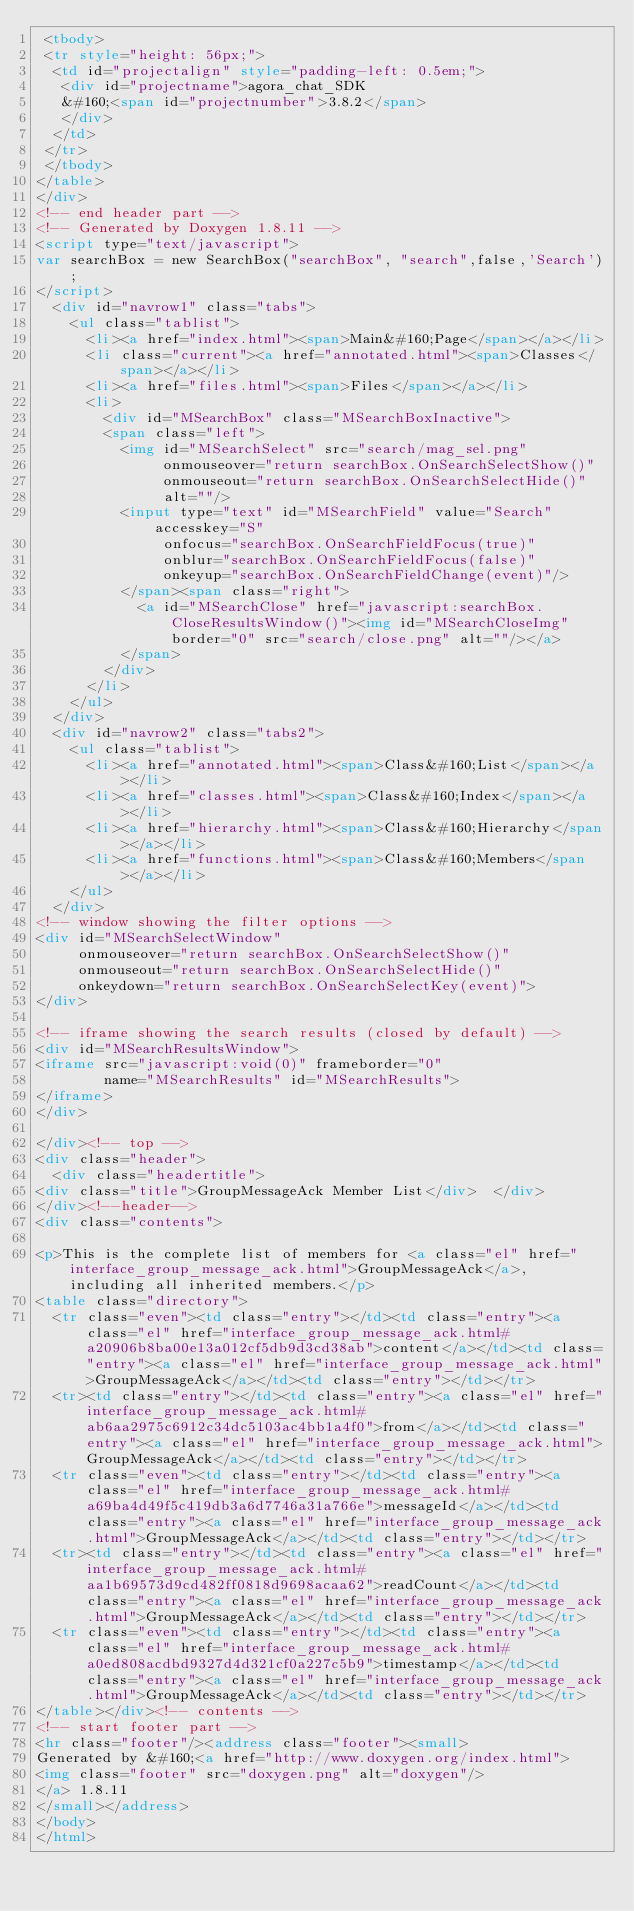Convert code to text. <code><loc_0><loc_0><loc_500><loc_500><_HTML_> <tbody>
 <tr style="height: 56px;">
  <td id="projectalign" style="padding-left: 0.5em;">
   <div id="projectname">agora_chat_SDK
   &#160;<span id="projectnumber">3.8.2</span>
   </div>
  </td>
 </tr>
 </tbody>
</table>
</div>
<!-- end header part -->
<!-- Generated by Doxygen 1.8.11 -->
<script type="text/javascript">
var searchBox = new SearchBox("searchBox", "search",false,'Search');
</script>
  <div id="navrow1" class="tabs">
    <ul class="tablist">
      <li><a href="index.html"><span>Main&#160;Page</span></a></li>
      <li class="current"><a href="annotated.html"><span>Classes</span></a></li>
      <li><a href="files.html"><span>Files</span></a></li>
      <li>
        <div id="MSearchBox" class="MSearchBoxInactive">
        <span class="left">
          <img id="MSearchSelect" src="search/mag_sel.png"
               onmouseover="return searchBox.OnSearchSelectShow()"
               onmouseout="return searchBox.OnSearchSelectHide()"
               alt=""/>
          <input type="text" id="MSearchField" value="Search" accesskey="S"
               onfocus="searchBox.OnSearchFieldFocus(true)" 
               onblur="searchBox.OnSearchFieldFocus(false)" 
               onkeyup="searchBox.OnSearchFieldChange(event)"/>
          </span><span class="right">
            <a id="MSearchClose" href="javascript:searchBox.CloseResultsWindow()"><img id="MSearchCloseImg" border="0" src="search/close.png" alt=""/></a>
          </span>
        </div>
      </li>
    </ul>
  </div>
  <div id="navrow2" class="tabs2">
    <ul class="tablist">
      <li><a href="annotated.html"><span>Class&#160;List</span></a></li>
      <li><a href="classes.html"><span>Class&#160;Index</span></a></li>
      <li><a href="hierarchy.html"><span>Class&#160;Hierarchy</span></a></li>
      <li><a href="functions.html"><span>Class&#160;Members</span></a></li>
    </ul>
  </div>
<!-- window showing the filter options -->
<div id="MSearchSelectWindow"
     onmouseover="return searchBox.OnSearchSelectShow()"
     onmouseout="return searchBox.OnSearchSelectHide()"
     onkeydown="return searchBox.OnSearchSelectKey(event)">
</div>

<!-- iframe showing the search results (closed by default) -->
<div id="MSearchResultsWindow">
<iframe src="javascript:void(0)" frameborder="0" 
        name="MSearchResults" id="MSearchResults">
</iframe>
</div>

</div><!-- top -->
<div class="header">
  <div class="headertitle">
<div class="title">GroupMessageAck Member List</div>  </div>
</div><!--header-->
<div class="contents">

<p>This is the complete list of members for <a class="el" href="interface_group_message_ack.html">GroupMessageAck</a>, including all inherited members.</p>
<table class="directory">
  <tr class="even"><td class="entry"></td><td class="entry"><a class="el" href="interface_group_message_ack.html#a20906b8ba00e13a012cf5db9d3cd38ab">content</a></td><td class="entry"><a class="el" href="interface_group_message_ack.html">GroupMessageAck</a></td><td class="entry"></td></tr>
  <tr><td class="entry"></td><td class="entry"><a class="el" href="interface_group_message_ack.html#ab6aa2975c6912c34dc5103ac4bb1a4f0">from</a></td><td class="entry"><a class="el" href="interface_group_message_ack.html">GroupMessageAck</a></td><td class="entry"></td></tr>
  <tr class="even"><td class="entry"></td><td class="entry"><a class="el" href="interface_group_message_ack.html#a69ba4d49f5c419db3a6d7746a31a766e">messageId</a></td><td class="entry"><a class="el" href="interface_group_message_ack.html">GroupMessageAck</a></td><td class="entry"></td></tr>
  <tr><td class="entry"></td><td class="entry"><a class="el" href="interface_group_message_ack.html#aa1b69573d9cd482ff0818d9698acaa62">readCount</a></td><td class="entry"><a class="el" href="interface_group_message_ack.html">GroupMessageAck</a></td><td class="entry"></td></tr>
  <tr class="even"><td class="entry"></td><td class="entry"><a class="el" href="interface_group_message_ack.html#a0ed808acdbd9327d4d321cf0a227c5b9">timestamp</a></td><td class="entry"><a class="el" href="interface_group_message_ack.html">GroupMessageAck</a></td><td class="entry"></td></tr>
</table></div><!-- contents -->
<!-- start footer part -->
<hr class="footer"/><address class="footer"><small>
Generated by &#160;<a href="http://www.doxygen.org/index.html">
<img class="footer" src="doxygen.png" alt="doxygen"/>
</a> 1.8.11
</small></address>
</body>
</html>
</code> 